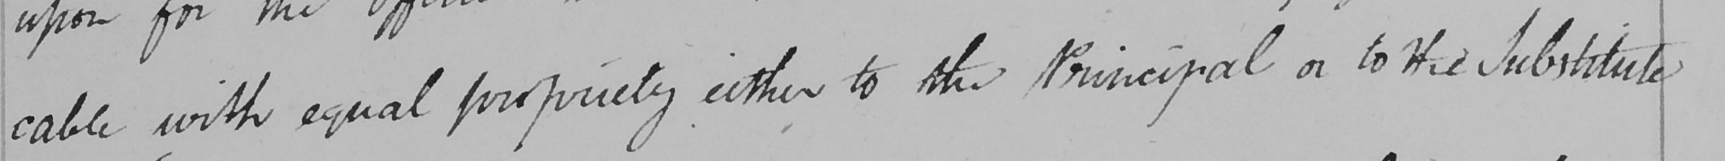What text is written in this handwritten line? cable with equal propriety either to the Principal or to His Substitute 